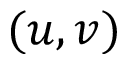<formula> <loc_0><loc_0><loc_500><loc_500>( u , v )</formula> 